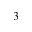Convert formula to latex. <formula><loc_0><loc_0><loc_500><loc_500>_ { 3 }</formula> 